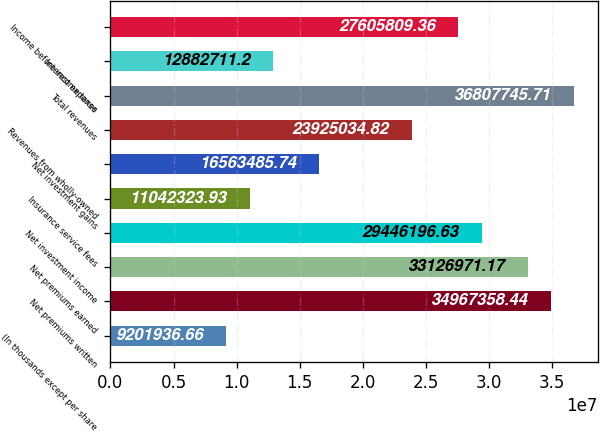Convert chart to OTSL. <chart><loc_0><loc_0><loc_500><loc_500><bar_chart><fcel>(In thousands except per share<fcel>Net premiums written<fcel>Net premiums earned<fcel>Net investment income<fcel>Insurance service fees<fcel>Net investment gains<fcel>Revenues from wholly-owned<fcel>Total revenues<fcel>Interest expense<fcel>Income before income taxes<nl><fcel>9.20194e+06<fcel>3.49674e+07<fcel>3.3127e+07<fcel>2.94462e+07<fcel>1.10423e+07<fcel>1.65635e+07<fcel>2.3925e+07<fcel>3.68077e+07<fcel>1.28827e+07<fcel>2.76058e+07<nl></chart> 